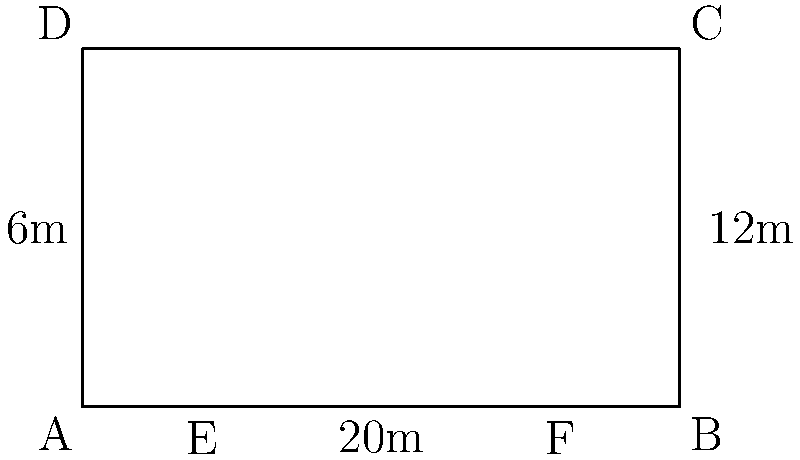For a cutting-edge fashion show, you're designing a sleek, modern runway. The stage is rectangular, measuring 20m in length and 12m in width. Models will enter from a 6m wide opening at the center of one of the shorter sides. If you want to create a triangular VIP section at the opposite end, occupying 20% of the total runway area, how far from the end of the runway should you place the dividing line for the VIP section? Let's approach this step-by-step:

1) First, we need to calculate the total area of the runway:
   Area = length × width = 20m × 12m = 240m²

2) The VIP section should occupy 20% of this area:
   VIP area = 20% × 240m² = 0.2 × 240m² = 48m²

3) Let's say the distance from the end of the runway to the VIP section dividing line is $x$ meters.

4) The VIP section will form a triangle. Its area can be calculated as:
   VIP area = $\frac{1}{2}$ × base × height
   48m² = $\frac{1}{2}$ × 12m × $x$

5) Solve for $x$:
   48m² = 6m × $x$
   $x$ = 48m² ÷ 6m = 8m

6) Therefore, the dividing line for the VIP section should be placed 8m from the end of the runway.

7) To double-check: 
   Triangle area = $\frac{1}{2}$ × 12m × 8m = 48m²
   This is indeed 20% of the total runway area (240m²).
Answer: 8m 